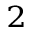Convert formula to latex. <formula><loc_0><loc_0><loc_500><loc_500>_ { 2 }</formula> 